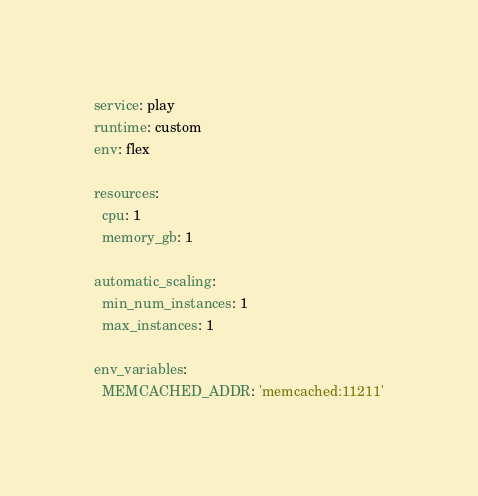Convert code to text. <code><loc_0><loc_0><loc_500><loc_500><_YAML_>service: play
runtime: custom
env: flex

resources:
  cpu: 1
  memory_gb: 1

automatic_scaling:
  min_num_instances: 1
  max_instances: 1

env_variables:
  MEMCACHED_ADDR: 'memcached:11211'
</code> 